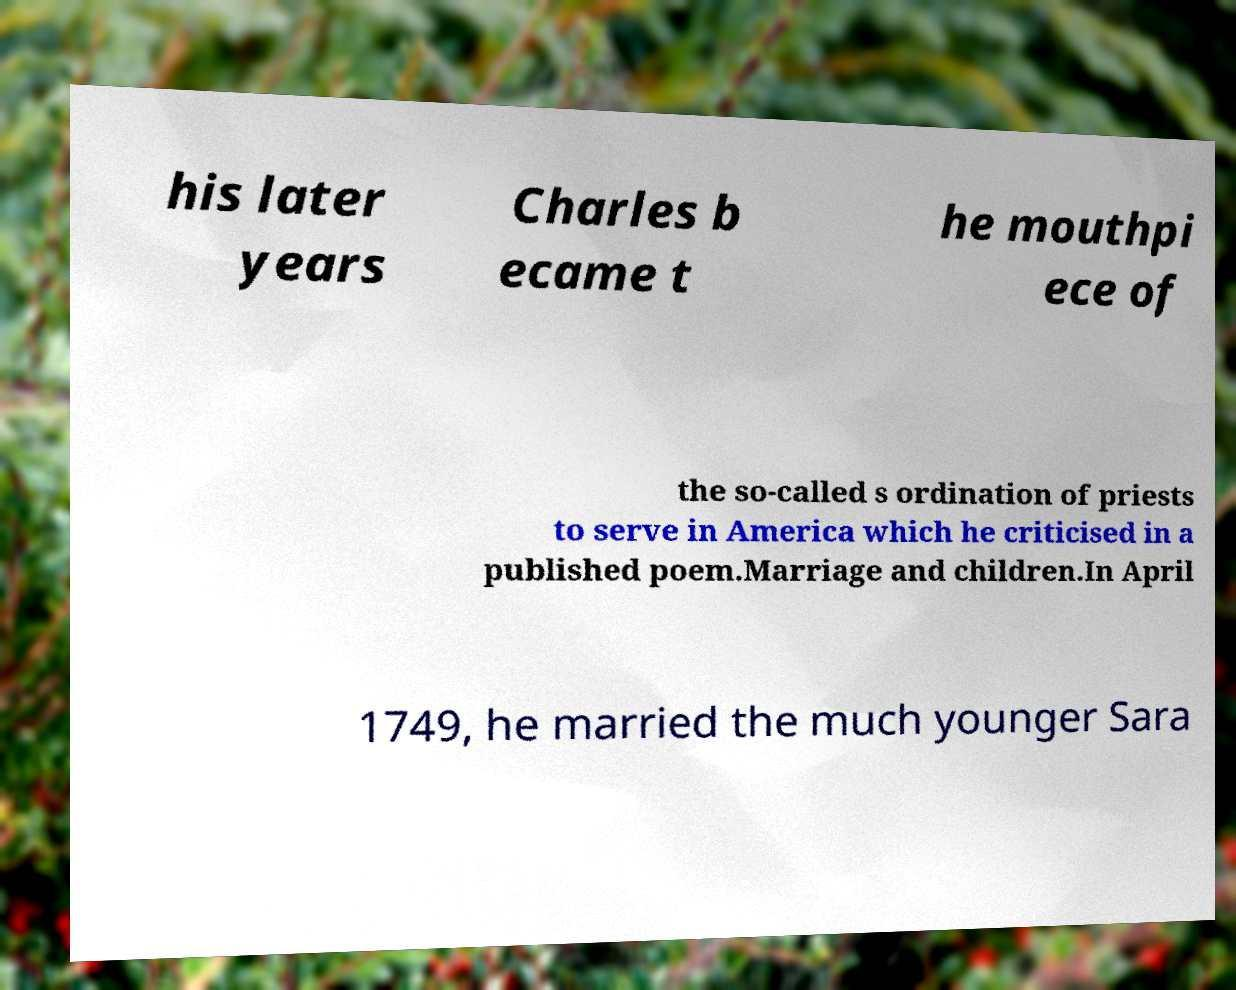I need the written content from this picture converted into text. Can you do that? his later years Charles b ecame t he mouthpi ece of the so-called s ordination of priests to serve in America which he criticised in a published poem.Marriage and children.In April 1749, he married the much younger Sara 